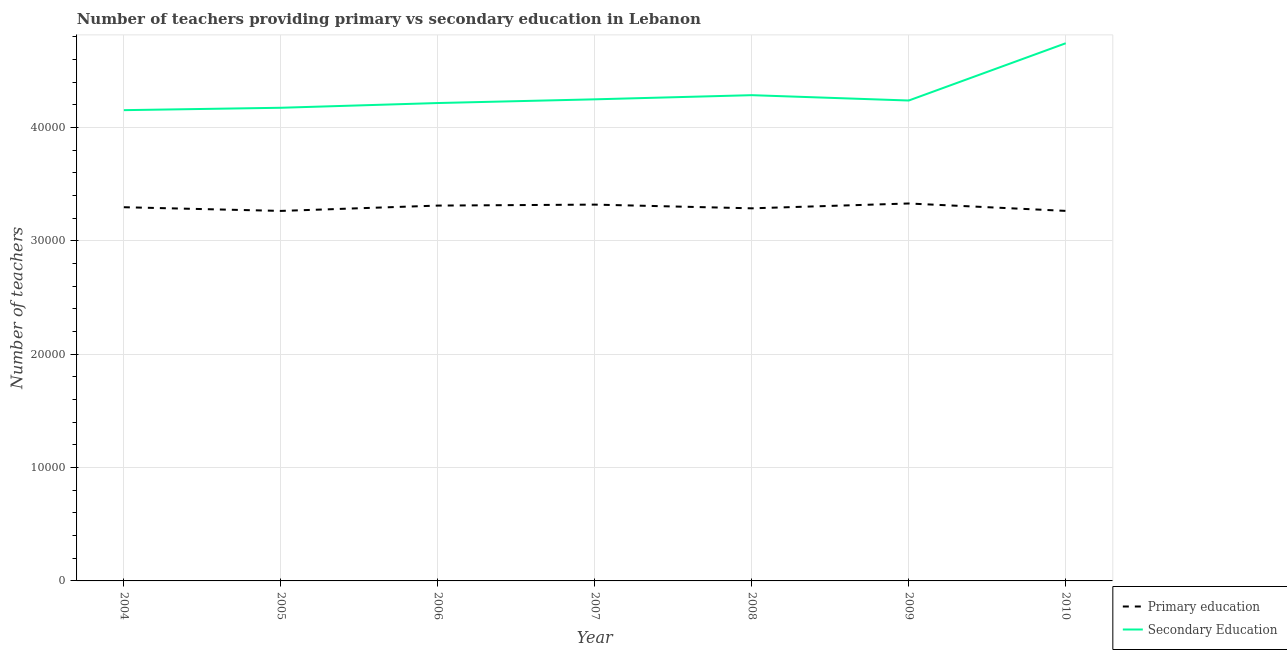Is the number of lines equal to the number of legend labels?
Ensure brevity in your answer.  Yes. What is the number of primary teachers in 2007?
Give a very brief answer. 3.32e+04. Across all years, what is the maximum number of secondary teachers?
Provide a short and direct response. 4.74e+04. Across all years, what is the minimum number of primary teachers?
Offer a very short reply. 3.26e+04. In which year was the number of secondary teachers maximum?
Provide a short and direct response. 2010. What is the total number of primary teachers in the graph?
Your answer should be very brief. 2.31e+05. What is the difference between the number of primary teachers in 2005 and that in 2008?
Your answer should be very brief. -229. What is the difference between the number of primary teachers in 2005 and the number of secondary teachers in 2008?
Offer a terse response. -1.02e+04. What is the average number of primary teachers per year?
Give a very brief answer. 3.30e+04. In the year 2010, what is the difference between the number of primary teachers and number of secondary teachers?
Make the answer very short. -1.48e+04. In how many years, is the number of secondary teachers greater than 24000?
Give a very brief answer. 7. What is the ratio of the number of secondary teachers in 2004 to that in 2008?
Provide a succinct answer. 0.97. Is the number of secondary teachers in 2005 less than that in 2007?
Your answer should be compact. Yes. Is the difference between the number of secondary teachers in 2007 and 2009 greater than the difference between the number of primary teachers in 2007 and 2009?
Your response must be concise. Yes. What is the difference between the highest and the second highest number of primary teachers?
Your answer should be compact. 100. What is the difference between the highest and the lowest number of primary teachers?
Ensure brevity in your answer.  656. Is the sum of the number of secondary teachers in 2009 and 2010 greater than the maximum number of primary teachers across all years?
Keep it short and to the point. Yes. Is the number of secondary teachers strictly greater than the number of primary teachers over the years?
Offer a very short reply. Yes. How many lines are there?
Provide a succinct answer. 2. How many years are there in the graph?
Offer a terse response. 7. What is the difference between two consecutive major ticks on the Y-axis?
Make the answer very short. 10000. Are the values on the major ticks of Y-axis written in scientific E-notation?
Make the answer very short. No. Does the graph contain any zero values?
Keep it short and to the point. No. Where does the legend appear in the graph?
Provide a short and direct response. Bottom right. How are the legend labels stacked?
Offer a very short reply. Vertical. What is the title of the graph?
Provide a succinct answer. Number of teachers providing primary vs secondary education in Lebanon. Does "Male entrants" appear as one of the legend labels in the graph?
Provide a succinct answer. No. What is the label or title of the Y-axis?
Ensure brevity in your answer.  Number of teachers. What is the Number of teachers in Primary education in 2004?
Provide a succinct answer. 3.30e+04. What is the Number of teachers in Secondary Education in 2004?
Keep it short and to the point. 4.15e+04. What is the Number of teachers of Primary education in 2005?
Your response must be concise. 3.26e+04. What is the Number of teachers in Secondary Education in 2005?
Ensure brevity in your answer.  4.17e+04. What is the Number of teachers of Primary education in 2006?
Make the answer very short. 3.31e+04. What is the Number of teachers of Secondary Education in 2006?
Keep it short and to the point. 4.22e+04. What is the Number of teachers of Primary education in 2007?
Provide a short and direct response. 3.32e+04. What is the Number of teachers in Secondary Education in 2007?
Your answer should be compact. 4.25e+04. What is the Number of teachers of Primary education in 2008?
Your answer should be compact. 3.29e+04. What is the Number of teachers in Secondary Education in 2008?
Offer a very short reply. 4.29e+04. What is the Number of teachers in Primary education in 2009?
Give a very brief answer. 3.33e+04. What is the Number of teachers in Secondary Education in 2009?
Make the answer very short. 4.24e+04. What is the Number of teachers in Primary education in 2010?
Provide a succinct answer. 3.26e+04. What is the Number of teachers of Secondary Education in 2010?
Provide a succinct answer. 4.74e+04. Across all years, what is the maximum Number of teachers in Primary education?
Your response must be concise. 3.33e+04. Across all years, what is the maximum Number of teachers of Secondary Education?
Your response must be concise. 4.74e+04. Across all years, what is the minimum Number of teachers in Primary education?
Ensure brevity in your answer.  3.26e+04. Across all years, what is the minimum Number of teachers in Secondary Education?
Your answer should be compact. 4.15e+04. What is the total Number of teachers of Primary education in the graph?
Give a very brief answer. 2.31e+05. What is the total Number of teachers of Secondary Education in the graph?
Your answer should be very brief. 3.01e+05. What is the difference between the Number of teachers of Primary education in 2004 and that in 2005?
Your answer should be compact. 326. What is the difference between the Number of teachers in Secondary Education in 2004 and that in 2005?
Provide a short and direct response. -211. What is the difference between the Number of teachers of Primary education in 2004 and that in 2006?
Ensure brevity in your answer.  -145. What is the difference between the Number of teachers of Secondary Education in 2004 and that in 2006?
Give a very brief answer. -629. What is the difference between the Number of teachers of Primary education in 2004 and that in 2007?
Keep it short and to the point. -230. What is the difference between the Number of teachers in Secondary Education in 2004 and that in 2007?
Give a very brief answer. -956. What is the difference between the Number of teachers in Primary education in 2004 and that in 2008?
Provide a succinct answer. 97. What is the difference between the Number of teachers in Secondary Education in 2004 and that in 2008?
Provide a short and direct response. -1322. What is the difference between the Number of teachers in Primary education in 2004 and that in 2009?
Make the answer very short. -330. What is the difference between the Number of teachers in Secondary Education in 2004 and that in 2009?
Ensure brevity in your answer.  -851. What is the difference between the Number of teachers of Primary education in 2004 and that in 2010?
Offer a terse response. 323. What is the difference between the Number of teachers of Secondary Education in 2004 and that in 2010?
Make the answer very short. -5903. What is the difference between the Number of teachers of Primary education in 2005 and that in 2006?
Your answer should be compact. -471. What is the difference between the Number of teachers in Secondary Education in 2005 and that in 2006?
Provide a succinct answer. -418. What is the difference between the Number of teachers in Primary education in 2005 and that in 2007?
Provide a succinct answer. -556. What is the difference between the Number of teachers of Secondary Education in 2005 and that in 2007?
Give a very brief answer. -745. What is the difference between the Number of teachers in Primary education in 2005 and that in 2008?
Provide a short and direct response. -229. What is the difference between the Number of teachers in Secondary Education in 2005 and that in 2008?
Offer a very short reply. -1111. What is the difference between the Number of teachers of Primary education in 2005 and that in 2009?
Provide a short and direct response. -656. What is the difference between the Number of teachers in Secondary Education in 2005 and that in 2009?
Provide a succinct answer. -640. What is the difference between the Number of teachers of Secondary Education in 2005 and that in 2010?
Your response must be concise. -5692. What is the difference between the Number of teachers of Primary education in 2006 and that in 2007?
Provide a short and direct response. -85. What is the difference between the Number of teachers in Secondary Education in 2006 and that in 2007?
Make the answer very short. -327. What is the difference between the Number of teachers in Primary education in 2006 and that in 2008?
Give a very brief answer. 242. What is the difference between the Number of teachers in Secondary Education in 2006 and that in 2008?
Ensure brevity in your answer.  -693. What is the difference between the Number of teachers in Primary education in 2006 and that in 2009?
Your answer should be compact. -185. What is the difference between the Number of teachers of Secondary Education in 2006 and that in 2009?
Ensure brevity in your answer.  -222. What is the difference between the Number of teachers in Primary education in 2006 and that in 2010?
Offer a very short reply. 468. What is the difference between the Number of teachers in Secondary Education in 2006 and that in 2010?
Your response must be concise. -5274. What is the difference between the Number of teachers of Primary education in 2007 and that in 2008?
Provide a succinct answer. 327. What is the difference between the Number of teachers in Secondary Education in 2007 and that in 2008?
Offer a terse response. -366. What is the difference between the Number of teachers of Primary education in 2007 and that in 2009?
Your answer should be very brief. -100. What is the difference between the Number of teachers in Secondary Education in 2007 and that in 2009?
Your response must be concise. 105. What is the difference between the Number of teachers of Primary education in 2007 and that in 2010?
Give a very brief answer. 553. What is the difference between the Number of teachers of Secondary Education in 2007 and that in 2010?
Keep it short and to the point. -4947. What is the difference between the Number of teachers in Primary education in 2008 and that in 2009?
Offer a very short reply. -427. What is the difference between the Number of teachers of Secondary Education in 2008 and that in 2009?
Provide a short and direct response. 471. What is the difference between the Number of teachers in Primary education in 2008 and that in 2010?
Your response must be concise. 226. What is the difference between the Number of teachers of Secondary Education in 2008 and that in 2010?
Offer a terse response. -4581. What is the difference between the Number of teachers in Primary education in 2009 and that in 2010?
Provide a succinct answer. 653. What is the difference between the Number of teachers of Secondary Education in 2009 and that in 2010?
Your response must be concise. -5052. What is the difference between the Number of teachers in Primary education in 2004 and the Number of teachers in Secondary Education in 2005?
Your answer should be compact. -8775. What is the difference between the Number of teachers in Primary education in 2004 and the Number of teachers in Secondary Education in 2006?
Offer a terse response. -9193. What is the difference between the Number of teachers of Primary education in 2004 and the Number of teachers of Secondary Education in 2007?
Offer a very short reply. -9520. What is the difference between the Number of teachers in Primary education in 2004 and the Number of teachers in Secondary Education in 2008?
Give a very brief answer. -9886. What is the difference between the Number of teachers of Primary education in 2004 and the Number of teachers of Secondary Education in 2009?
Provide a short and direct response. -9415. What is the difference between the Number of teachers in Primary education in 2004 and the Number of teachers in Secondary Education in 2010?
Ensure brevity in your answer.  -1.45e+04. What is the difference between the Number of teachers of Primary education in 2005 and the Number of teachers of Secondary Education in 2006?
Keep it short and to the point. -9519. What is the difference between the Number of teachers in Primary education in 2005 and the Number of teachers in Secondary Education in 2007?
Keep it short and to the point. -9846. What is the difference between the Number of teachers in Primary education in 2005 and the Number of teachers in Secondary Education in 2008?
Ensure brevity in your answer.  -1.02e+04. What is the difference between the Number of teachers in Primary education in 2005 and the Number of teachers in Secondary Education in 2009?
Keep it short and to the point. -9741. What is the difference between the Number of teachers of Primary education in 2005 and the Number of teachers of Secondary Education in 2010?
Your response must be concise. -1.48e+04. What is the difference between the Number of teachers in Primary education in 2006 and the Number of teachers in Secondary Education in 2007?
Provide a succinct answer. -9375. What is the difference between the Number of teachers of Primary education in 2006 and the Number of teachers of Secondary Education in 2008?
Make the answer very short. -9741. What is the difference between the Number of teachers of Primary education in 2006 and the Number of teachers of Secondary Education in 2009?
Provide a short and direct response. -9270. What is the difference between the Number of teachers in Primary education in 2006 and the Number of teachers in Secondary Education in 2010?
Offer a terse response. -1.43e+04. What is the difference between the Number of teachers of Primary education in 2007 and the Number of teachers of Secondary Education in 2008?
Make the answer very short. -9656. What is the difference between the Number of teachers in Primary education in 2007 and the Number of teachers in Secondary Education in 2009?
Ensure brevity in your answer.  -9185. What is the difference between the Number of teachers in Primary education in 2007 and the Number of teachers in Secondary Education in 2010?
Provide a short and direct response. -1.42e+04. What is the difference between the Number of teachers in Primary education in 2008 and the Number of teachers in Secondary Education in 2009?
Give a very brief answer. -9512. What is the difference between the Number of teachers in Primary education in 2008 and the Number of teachers in Secondary Education in 2010?
Your response must be concise. -1.46e+04. What is the difference between the Number of teachers in Primary education in 2009 and the Number of teachers in Secondary Education in 2010?
Your response must be concise. -1.41e+04. What is the average Number of teachers of Primary education per year?
Your response must be concise. 3.30e+04. What is the average Number of teachers in Secondary Education per year?
Your response must be concise. 4.29e+04. In the year 2004, what is the difference between the Number of teachers in Primary education and Number of teachers in Secondary Education?
Provide a succinct answer. -8564. In the year 2005, what is the difference between the Number of teachers of Primary education and Number of teachers of Secondary Education?
Ensure brevity in your answer.  -9101. In the year 2006, what is the difference between the Number of teachers in Primary education and Number of teachers in Secondary Education?
Offer a terse response. -9048. In the year 2007, what is the difference between the Number of teachers in Primary education and Number of teachers in Secondary Education?
Your answer should be very brief. -9290. In the year 2008, what is the difference between the Number of teachers of Primary education and Number of teachers of Secondary Education?
Offer a very short reply. -9983. In the year 2009, what is the difference between the Number of teachers of Primary education and Number of teachers of Secondary Education?
Your answer should be very brief. -9085. In the year 2010, what is the difference between the Number of teachers of Primary education and Number of teachers of Secondary Education?
Keep it short and to the point. -1.48e+04. What is the ratio of the Number of teachers of Primary education in 2004 to that in 2005?
Provide a succinct answer. 1.01. What is the ratio of the Number of teachers of Secondary Education in 2004 to that in 2005?
Give a very brief answer. 0.99. What is the ratio of the Number of teachers in Secondary Education in 2004 to that in 2006?
Provide a short and direct response. 0.99. What is the ratio of the Number of teachers of Primary education in 2004 to that in 2007?
Your answer should be compact. 0.99. What is the ratio of the Number of teachers of Secondary Education in 2004 to that in 2007?
Provide a succinct answer. 0.98. What is the ratio of the Number of teachers in Primary education in 2004 to that in 2008?
Your answer should be very brief. 1. What is the ratio of the Number of teachers in Secondary Education in 2004 to that in 2008?
Provide a short and direct response. 0.97. What is the ratio of the Number of teachers of Secondary Education in 2004 to that in 2009?
Your response must be concise. 0.98. What is the ratio of the Number of teachers in Primary education in 2004 to that in 2010?
Provide a succinct answer. 1.01. What is the ratio of the Number of teachers in Secondary Education in 2004 to that in 2010?
Offer a very short reply. 0.88. What is the ratio of the Number of teachers of Primary education in 2005 to that in 2006?
Keep it short and to the point. 0.99. What is the ratio of the Number of teachers of Secondary Education in 2005 to that in 2006?
Keep it short and to the point. 0.99. What is the ratio of the Number of teachers in Primary education in 2005 to that in 2007?
Make the answer very short. 0.98. What is the ratio of the Number of teachers of Secondary Education in 2005 to that in 2007?
Provide a short and direct response. 0.98. What is the ratio of the Number of teachers of Secondary Education in 2005 to that in 2008?
Ensure brevity in your answer.  0.97. What is the ratio of the Number of teachers in Primary education in 2005 to that in 2009?
Provide a succinct answer. 0.98. What is the ratio of the Number of teachers of Secondary Education in 2005 to that in 2009?
Offer a very short reply. 0.98. What is the ratio of the Number of teachers in Primary education in 2005 to that in 2010?
Give a very brief answer. 1. What is the ratio of the Number of teachers of Secondary Education in 2006 to that in 2007?
Your answer should be very brief. 0.99. What is the ratio of the Number of teachers in Primary education in 2006 to that in 2008?
Give a very brief answer. 1.01. What is the ratio of the Number of teachers in Secondary Education in 2006 to that in 2008?
Ensure brevity in your answer.  0.98. What is the ratio of the Number of teachers in Primary education in 2006 to that in 2009?
Give a very brief answer. 0.99. What is the ratio of the Number of teachers of Primary education in 2006 to that in 2010?
Provide a short and direct response. 1.01. What is the ratio of the Number of teachers of Secondary Education in 2006 to that in 2010?
Offer a terse response. 0.89. What is the ratio of the Number of teachers of Primary education in 2007 to that in 2008?
Offer a very short reply. 1.01. What is the ratio of the Number of teachers of Secondary Education in 2007 to that in 2008?
Provide a succinct answer. 0.99. What is the ratio of the Number of teachers in Secondary Education in 2007 to that in 2009?
Offer a terse response. 1. What is the ratio of the Number of teachers of Primary education in 2007 to that in 2010?
Your response must be concise. 1.02. What is the ratio of the Number of teachers of Secondary Education in 2007 to that in 2010?
Offer a very short reply. 0.9. What is the ratio of the Number of teachers in Primary education in 2008 to that in 2009?
Make the answer very short. 0.99. What is the ratio of the Number of teachers of Secondary Education in 2008 to that in 2009?
Provide a succinct answer. 1.01. What is the ratio of the Number of teachers of Primary education in 2008 to that in 2010?
Your answer should be very brief. 1.01. What is the ratio of the Number of teachers in Secondary Education in 2008 to that in 2010?
Ensure brevity in your answer.  0.9. What is the ratio of the Number of teachers in Secondary Education in 2009 to that in 2010?
Make the answer very short. 0.89. What is the difference between the highest and the second highest Number of teachers in Primary education?
Your answer should be very brief. 100. What is the difference between the highest and the second highest Number of teachers of Secondary Education?
Offer a terse response. 4581. What is the difference between the highest and the lowest Number of teachers in Primary education?
Offer a terse response. 656. What is the difference between the highest and the lowest Number of teachers of Secondary Education?
Your response must be concise. 5903. 